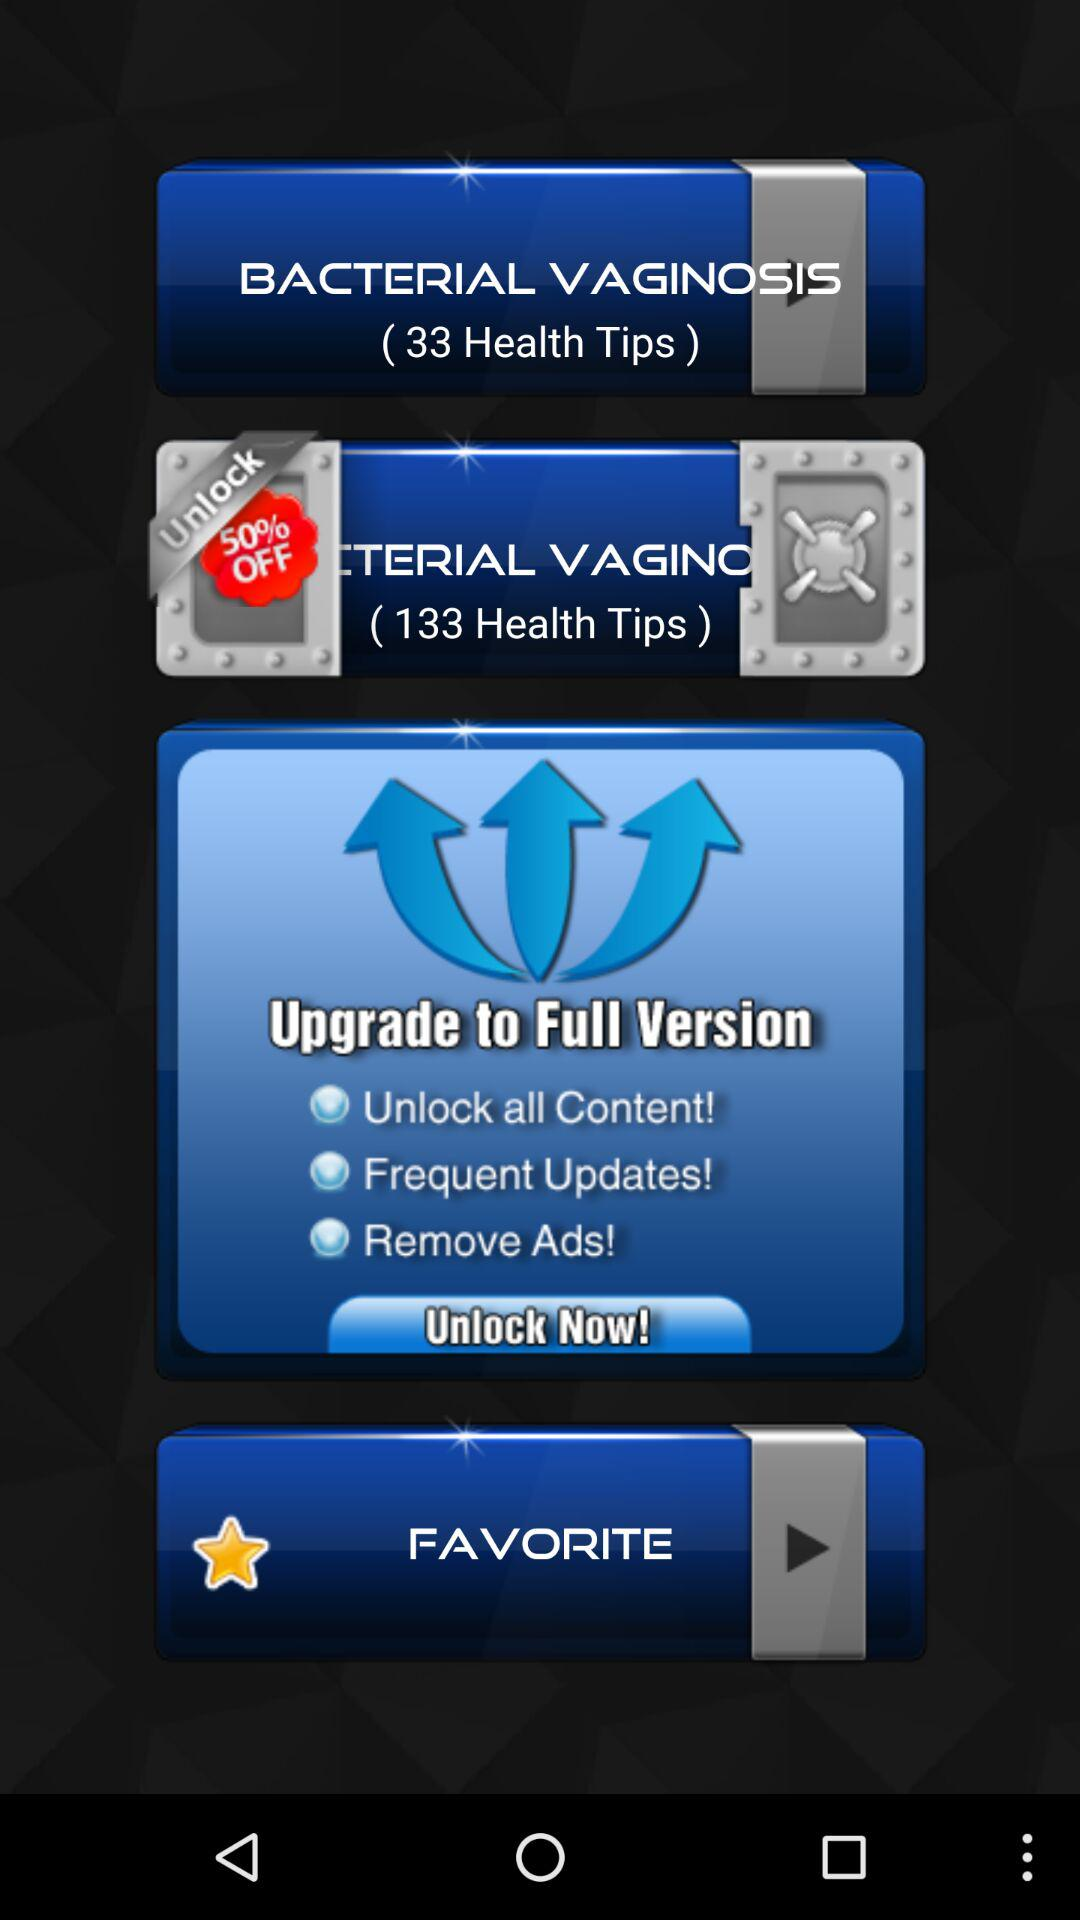How many health tips are there for bacterial vaginosis? There are 33 health tips. 